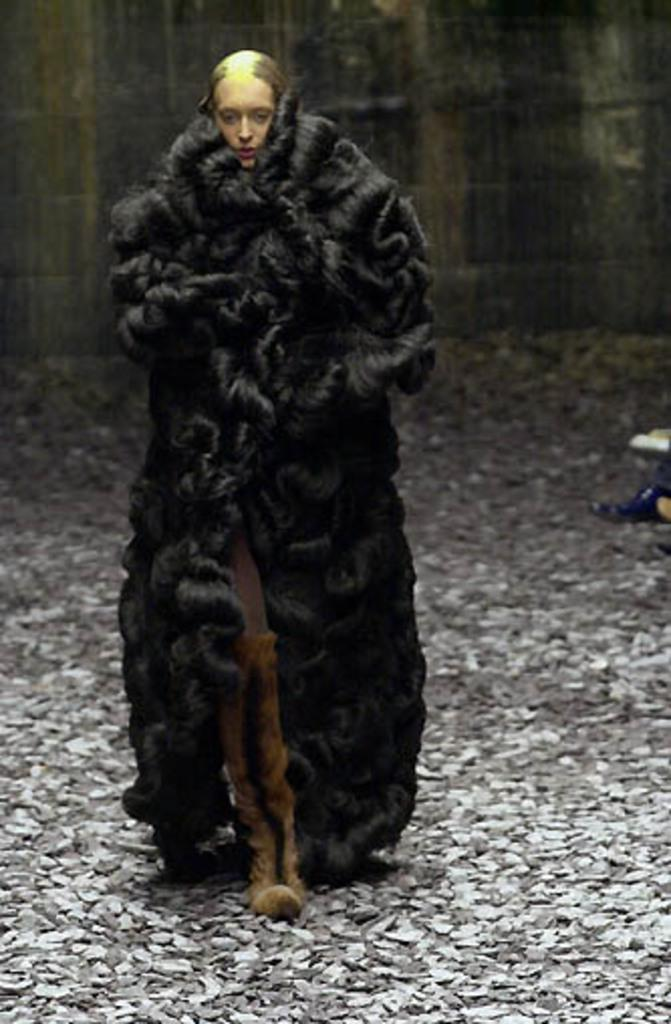What is the woman in the image doing? The woman is walking in the image. What can be seen on the ground in the image? Let's think step by step in order to produce the conversation. We start by identifying the main subject in the image, which is the woman walking. Then, we describe the ground in the image, mentioning that there are stones. Next, we acknowledge the presence of a person's leg, which suggests that there may be more than one person in the image. Finally, we describe the background, noting that there is a wall. Absurd Question/Answer: What type of beds can be seen in the image? There are no beds present in the image. What religious symbols can be seen in the image? There are no religious symbols present in the image. What type of sister can be seen in the image? There is no mention of a sister or any family members in the image. 